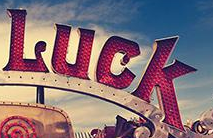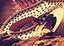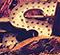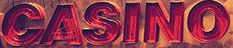What words can you see in these images in sequence, separated by a semicolon? Luck; #; S; CASINO 